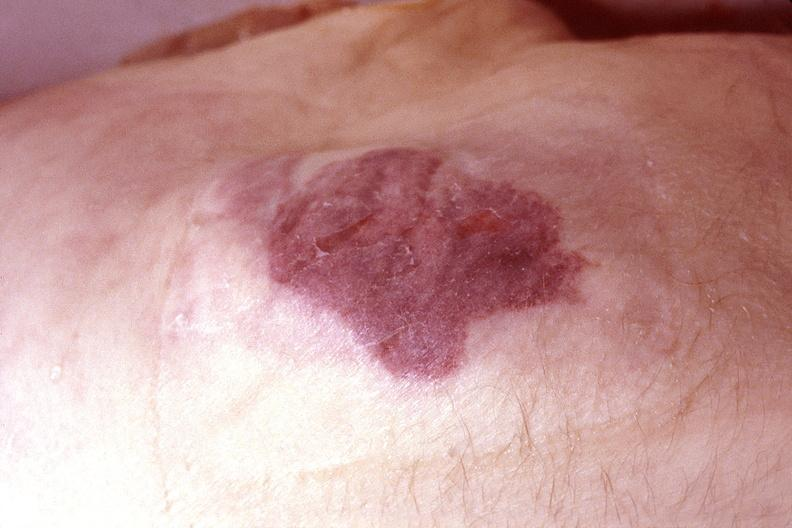does this image show skin, kaposis 's sarcoma?
Answer the question using a single word or phrase. Yes 